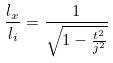Convert formula to latex. <formula><loc_0><loc_0><loc_500><loc_500>\frac { l _ { x } } { l _ { i } } = \frac { 1 } { \sqrt { 1 - \frac { t ^ { 2 } } { j ^ { 2 } } } }</formula> 